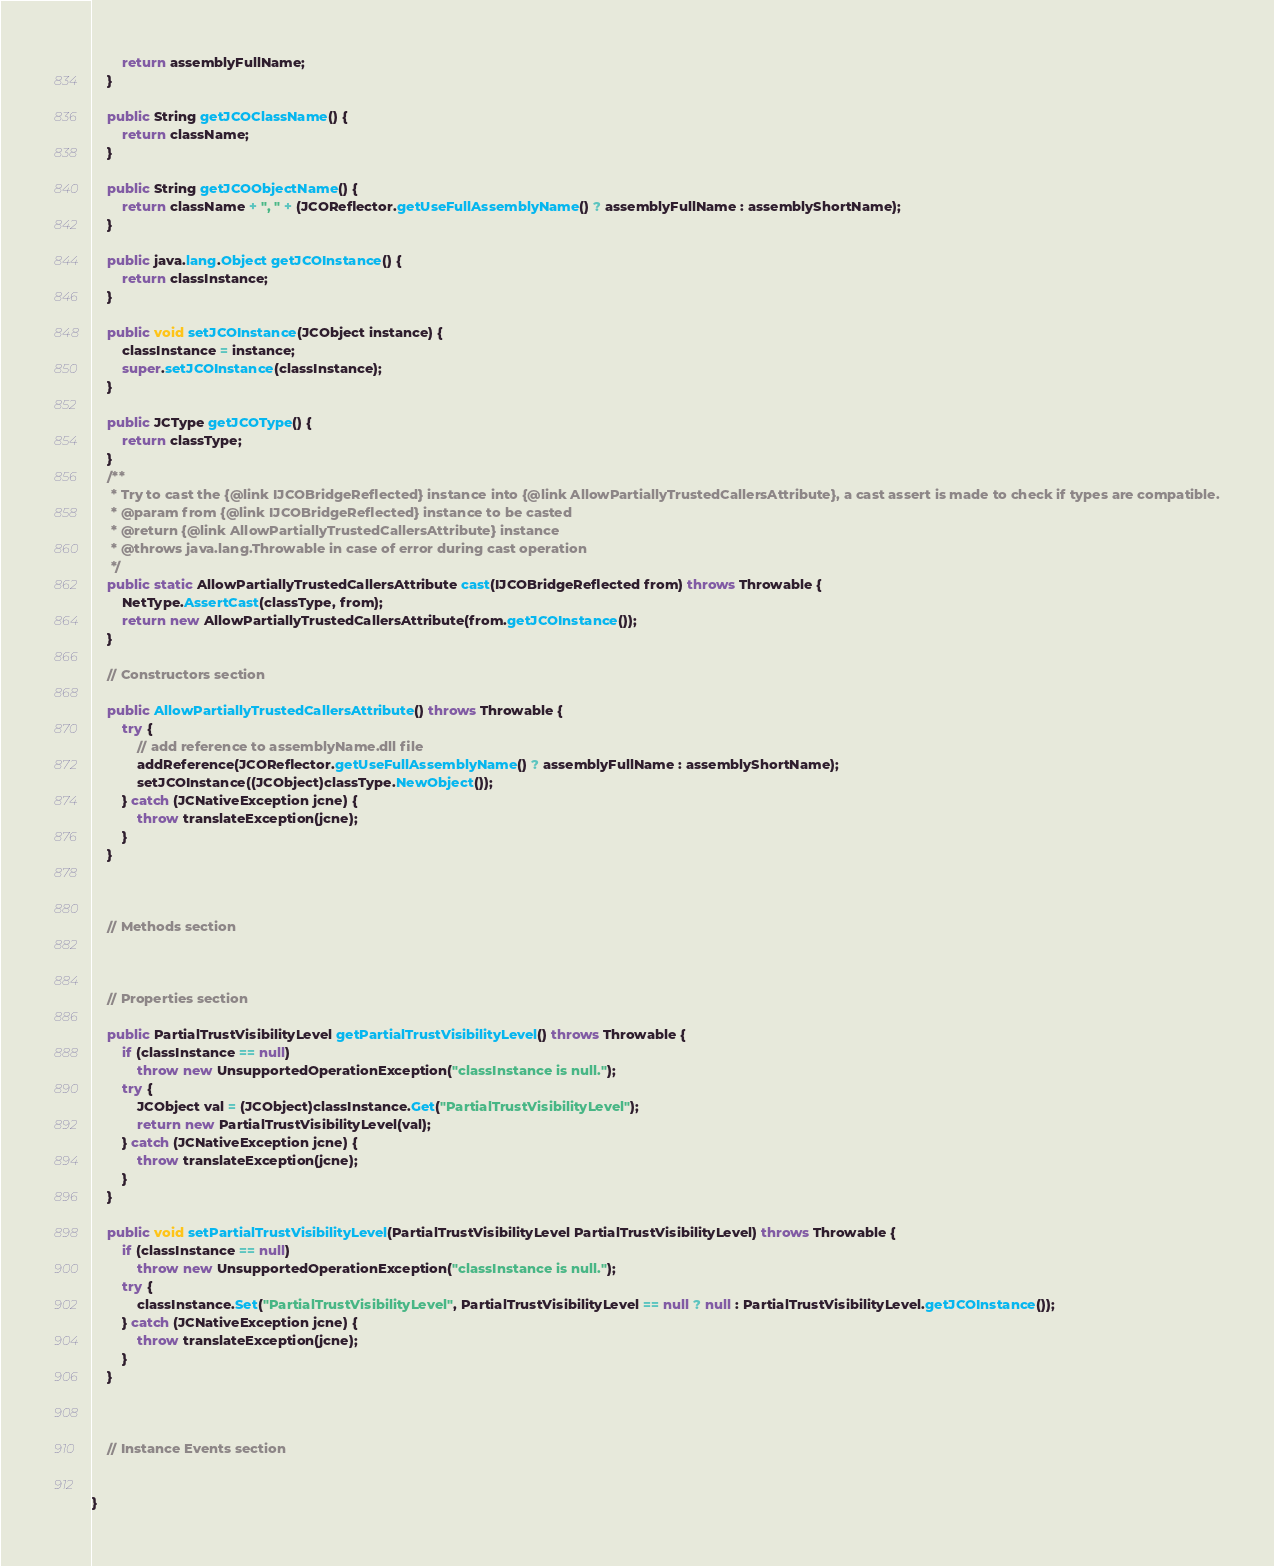Convert code to text. <code><loc_0><loc_0><loc_500><loc_500><_Java_>        return assemblyFullName;
    }

    public String getJCOClassName() {
        return className;
    }

    public String getJCOObjectName() {
        return className + ", " + (JCOReflector.getUseFullAssemblyName() ? assemblyFullName : assemblyShortName);
    }

    public java.lang.Object getJCOInstance() {
        return classInstance;
    }

    public void setJCOInstance(JCObject instance) {
        classInstance = instance;
        super.setJCOInstance(classInstance);
    }

    public JCType getJCOType() {
        return classType;
    }
    /**
     * Try to cast the {@link IJCOBridgeReflected} instance into {@link AllowPartiallyTrustedCallersAttribute}, a cast assert is made to check if types are compatible.
     * @param from {@link IJCOBridgeReflected} instance to be casted
     * @return {@link AllowPartiallyTrustedCallersAttribute} instance
     * @throws java.lang.Throwable in case of error during cast operation
     */
    public static AllowPartiallyTrustedCallersAttribute cast(IJCOBridgeReflected from) throws Throwable {
        NetType.AssertCast(classType, from);
        return new AllowPartiallyTrustedCallersAttribute(from.getJCOInstance());
    }

    // Constructors section
    
    public AllowPartiallyTrustedCallersAttribute() throws Throwable {
        try {
            // add reference to assemblyName.dll file
            addReference(JCOReflector.getUseFullAssemblyName() ? assemblyFullName : assemblyShortName);
            setJCOInstance((JCObject)classType.NewObject());
        } catch (JCNativeException jcne) {
            throw translateException(jcne);
        }
    }


    
    // Methods section
    

    
    // Properties section
    
    public PartialTrustVisibilityLevel getPartialTrustVisibilityLevel() throws Throwable {
        if (classInstance == null)
            throw new UnsupportedOperationException("classInstance is null.");
        try {
            JCObject val = (JCObject)classInstance.Get("PartialTrustVisibilityLevel");
            return new PartialTrustVisibilityLevel(val);
        } catch (JCNativeException jcne) {
            throw translateException(jcne);
        }
    }

    public void setPartialTrustVisibilityLevel(PartialTrustVisibilityLevel PartialTrustVisibilityLevel) throws Throwable {
        if (classInstance == null)
            throw new UnsupportedOperationException("classInstance is null.");
        try {
            classInstance.Set("PartialTrustVisibilityLevel", PartialTrustVisibilityLevel == null ? null : PartialTrustVisibilityLevel.getJCOInstance());
        } catch (JCNativeException jcne) {
            throw translateException(jcne);
        }
    }



    // Instance Events section
    

}</code> 